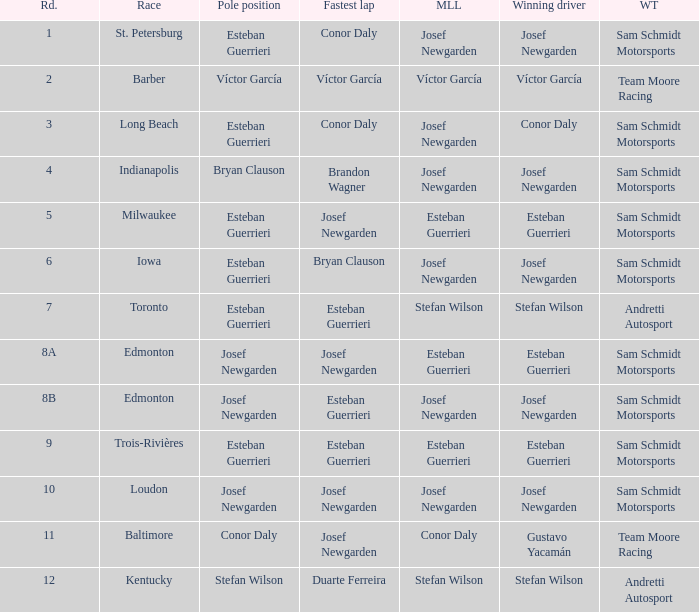Who had the fastest lap(s) when stefan wilson had the pole? Duarte Ferreira. 